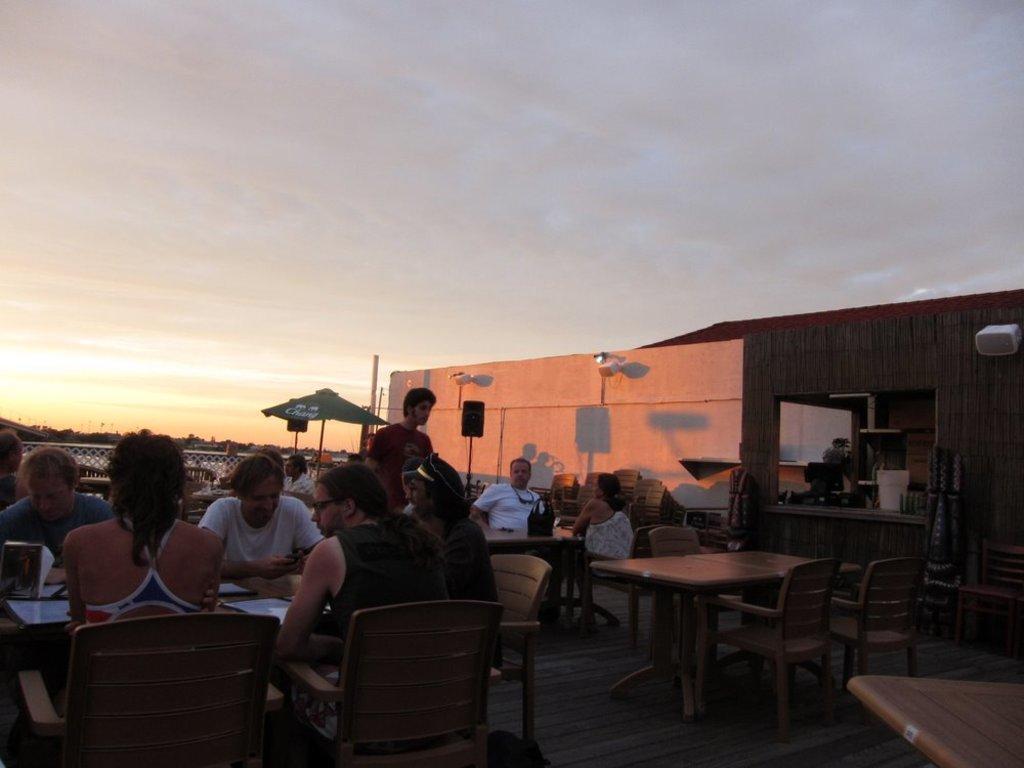Could you give a brief overview of what you see in this image? This is a picture taken in the out door, this is a roof top restaurant and the people are siting on the chairs in front there is a table on the table there are the files these is a wooden floor. The top of them is sky with clouds. 